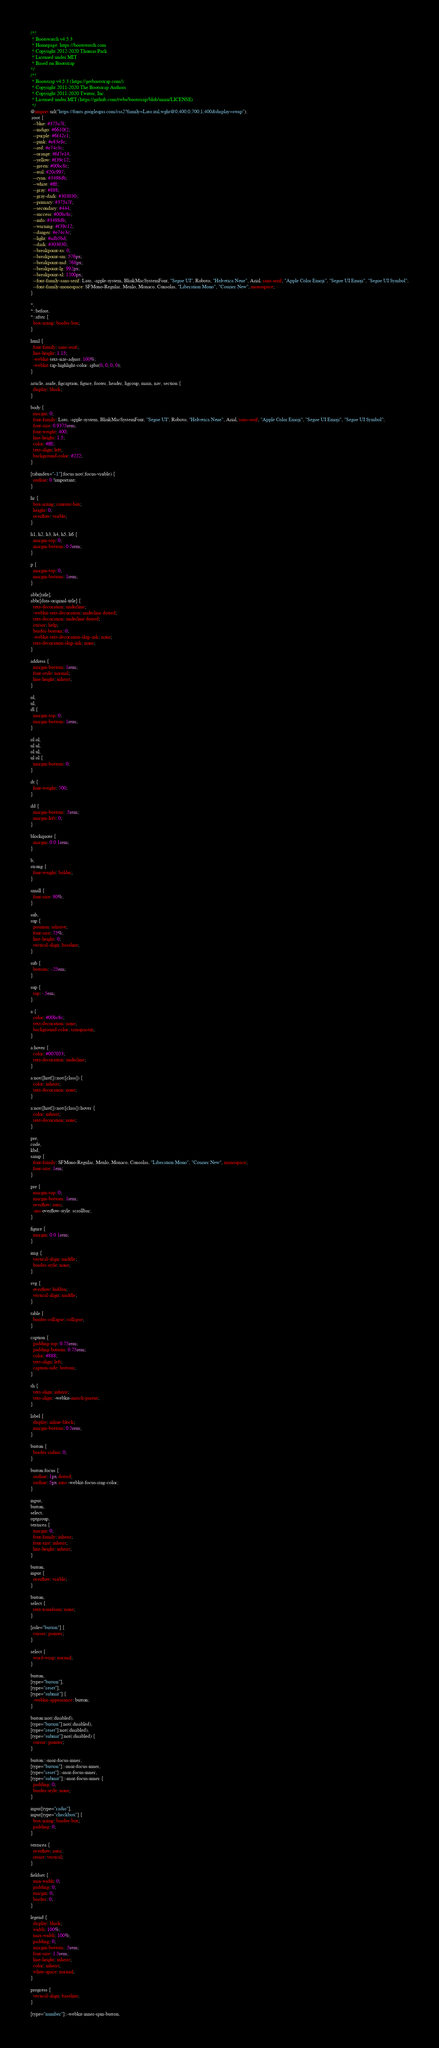<code> <loc_0><loc_0><loc_500><loc_500><_CSS_>/*!
 * Bootswatch v4.5.3
 * Homepage: https://bootswatch.com
 * Copyright 2012-2020 Thomas Park
 * Licensed under MIT
 * Based on Bootstrap
*/
/*!
 * Bootstrap v4.5.3 (https://getbootstrap.com/)
 * Copyright 2011-2020 The Bootstrap Authors
 * Copyright 2011-2020 Twitter, Inc.
 * Licensed under MIT (https://github.com/twbs/bootstrap/blob/main/LICENSE)
 */
@import url("https://fonts.googleapis.com/css2?family=Lato:ital,wght@0,400;0,700;1,400&display=swap");
:root {
  --blue: #375a7f;
  --indigo: #6610f2;
  --purple: #6f42c1;
  --pink: #e83e8c;
  --red: #e74c3c;
  --orange: #fd7e14;
  --yellow: #f39c12;
  --green: #00bc8c;
  --teal: #20c997;
  --cyan: #3498db;
  --white: #fff;
  --gray: #888;
  --gray-dark: #303030;
  --primary: #375a7f;
  --secondary: #444;
  --success: #00bc8c;
  --info: #3498db;
  --warning: #f39c12;
  --danger: #e74c3c;
  --light: #adb5bd;
  --dark: #303030;
  --breakpoint-xs: 0;
  --breakpoint-sm: 576px;
  --breakpoint-md: 768px;
  --breakpoint-lg: 992px;
  --breakpoint-xl: 1200px;
  --font-family-sans-serif: Lato, -apple-system, BlinkMacSystemFont, "Segoe UI", Roboto, "Helvetica Neue", Arial, sans-serif, "Apple Color Emoji", "Segoe UI Emoji", "Segoe UI Symbol";
  --font-family-monospace: SFMono-Regular, Menlo, Monaco, Consolas, "Liberation Mono", "Courier New", monospace;
}

*,
*::before,
*::after {
  box-sizing: border-box;
}

html {
  font-family: sans-serif;
  line-height: 1.15;
  -webkit-text-size-adjust: 100%;
  -webkit-tap-highlight-color: rgba(0, 0, 0, 0);
}

article, aside, figcaption, figure, footer, header, hgroup, main, nav, section {
  display: block;
}

body {
  margin: 0;
  font-family: Lato, -apple-system, BlinkMacSystemFont, "Segoe UI", Roboto, "Helvetica Neue", Arial, sans-serif, "Apple Color Emoji", "Segoe UI Emoji", "Segoe UI Symbol";
  font-size: 0.9375rem;
  font-weight: 400;
  line-height: 1.5;
  color: #fff;
  text-align: left;
  background-color: #222;
}

[tabindex="-1"]:focus:not(:focus-visible) {
  outline: 0 !important;
}

hr {
  box-sizing: content-box;
  height: 0;
  overflow: visible;
}

h1, h2, h3, h4, h5, h6 {
  margin-top: 0;
  margin-bottom: 0.5rem;
}

p {
  margin-top: 0;
  margin-bottom: 1rem;
}

abbr[title],
abbr[data-original-title] {
  text-decoration: underline;
  -webkit-text-decoration: underline dotted;
  text-decoration: underline dotted;
  cursor: help;
  border-bottom: 0;
  -webkit-text-decoration-skip-ink: none;
  text-decoration-skip-ink: none;
}

address {
  margin-bottom: 1rem;
  font-style: normal;
  line-height: inherit;
}

ol,
ul,
dl {
  margin-top: 0;
  margin-bottom: 1rem;
}

ol ol,
ul ul,
ol ul,
ul ol {
  margin-bottom: 0;
}

dt {
  font-weight: 700;
}

dd {
  margin-bottom: .5rem;
  margin-left: 0;
}

blockquote {
  margin: 0 0 1rem;
}

b,
strong {
  font-weight: bolder;
}

small {
  font-size: 80%;
}

sub,
sup {
  position: relative;
  font-size: 75%;
  line-height: 0;
  vertical-align: baseline;
}

sub {
  bottom: -.25em;
}

sup {
  top: -.5em;
}

a {
  color: #00bc8c;
  text-decoration: none;
  background-color: transparent;
}

a:hover {
  color: #007053;
  text-decoration: underline;
}

a:not([href]):not([class]) {
  color: inherit;
  text-decoration: none;
}

a:not([href]):not([class]):hover {
  color: inherit;
  text-decoration: none;
}

pre,
code,
kbd,
samp {
  font-family: SFMono-Regular, Menlo, Monaco, Consolas, "Liberation Mono", "Courier New", monospace;
  font-size: 1em;
}

pre {
  margin-top: 0;
  margin-bottom: 1rem;
  overflow: auto;
  -ms-overflow-style: scrollbar;
}

figure {
  margin: 0 0 1rem;
}

img {
  vertical-align: middle;
  border-style: none;
}

svg {
  overflow: hidden;
  vertical-align: middle;
}

table {
  border-collapse: collapse;
}

caption {
  padding-top: 0.75rem;
  padding-bottom: 0.75rem;
  color: #888;
  text-align: left;
  caption-side: bottom;
}

th {
  text-align: inherit;
  text-align: -webkit-match-parent;
}

label {
  display: inline-block;
  margin-bottom: 0.5rem;
}

button {
  border-radius: 0;
}

button:focus {
  outline: 1px dotted;
  outline: 5px auto -webkit-focus-ring-color;
}

input,
button,
select,
optgroup,
textarea {
  margin: 0;
  font-family: inherit;
  font-size: inherit;
  line-height: inherit;
}

button,
input {
  overflow: visible;
}

button,
select {
  text-transform: none;
}

[role="button"] {
  cursor: pointer;
}

select {
  word-wrap: normal;
}

button,
[type="button"],
[type="reset"],
[type="submit"] {
  -webkit-appearance: button;
}

button:not(:disabled),
[type="button"]:not(:disabled),
[type="reset"]:not(:disabled),
[type="submit"]:not(:disabled) {
  cursor: pointer;
}

button::-moz-focus-inner,
[type="button"]::-moz-focus-inner,
[type="reset"]::-moz-focus-inner,
[type="submit"]::-moz-focus-inner {
  padding: 0;
  border-style: none;
}

input[type="radio"],
input[type="checkbox"] {
  box-sizing: border-box;
  padding: 0;
}

textarea {
  overflow: auto;
  resize: vertical;
}

fieldset {
  min-width: 0;
  padding: 0;
  margin: 0;
  border: 0;
}

legend {
  display: block;
  width: 100%;
  max-width: 100%;
  padding: 0;
  margin-bottom: .5rem;
  font-size: 1.5rem;
  line-height: inherit;
  color: inherit;
  white-space: normal;
}

progress {
  vertical-align: baseline;
}

[type="number"]::-webkit-inner-spin-button,</code> 